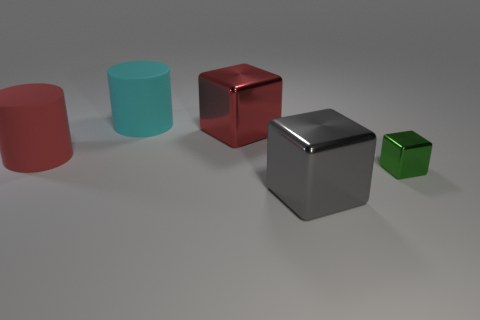Subtract all big red blocks. How many blocks are left? 2 Subtract all green cubes. How many cubes are left? 2 Subtract 2 cylinders. How many cylinders are left? 0 Add 3 small yellow metallic balls. How many objects exist? 8 Subtract all cylinders. How many objects are left? 3 Add 5 big red rubber things. How many big red rubber things exist? 6 Subtract 0 red balls. How many objects are left? 5 Subtract all blue cylinders. Subtract all gray blocks. How many cylinders are left? 2 Subtract all brown blocks. How many cyan cylinders are left? 1 Subtract all purple metallic blocks. Subtract all large rubber objects. How many objects are left? 3 